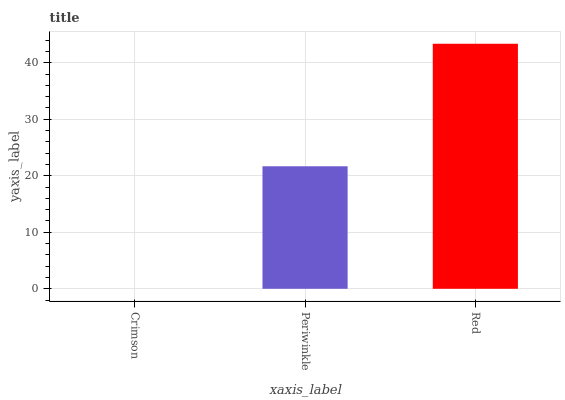Is Crimson the minimum?
Answer yes or no. Yes. Is Red the maximum?
Answer yes or no. Yes. Is Periwinkle the minimum?
Answer yes or no. No. Is Periwinkle the maximum?
Answer yes or no. No. Is Periwinkle greater than Crimson?
Answer yes or no. Yes. Is Crimson less than Periwinkle?
Answer yes or no. Yes. Is Crimson greater than Periwinkle?
Answer yes or no. No. Is Periwinkle less than Crimson?
Answer yes or no. No. Is Periwinkle the high median?
Answer yes or no. Yes. Is Periwinkle the low median?
Answer yes or no. Yes. Is Crimson the high median?
Answer yes or no. No. Is Crimson the low median?
Answer yes or no. No. 